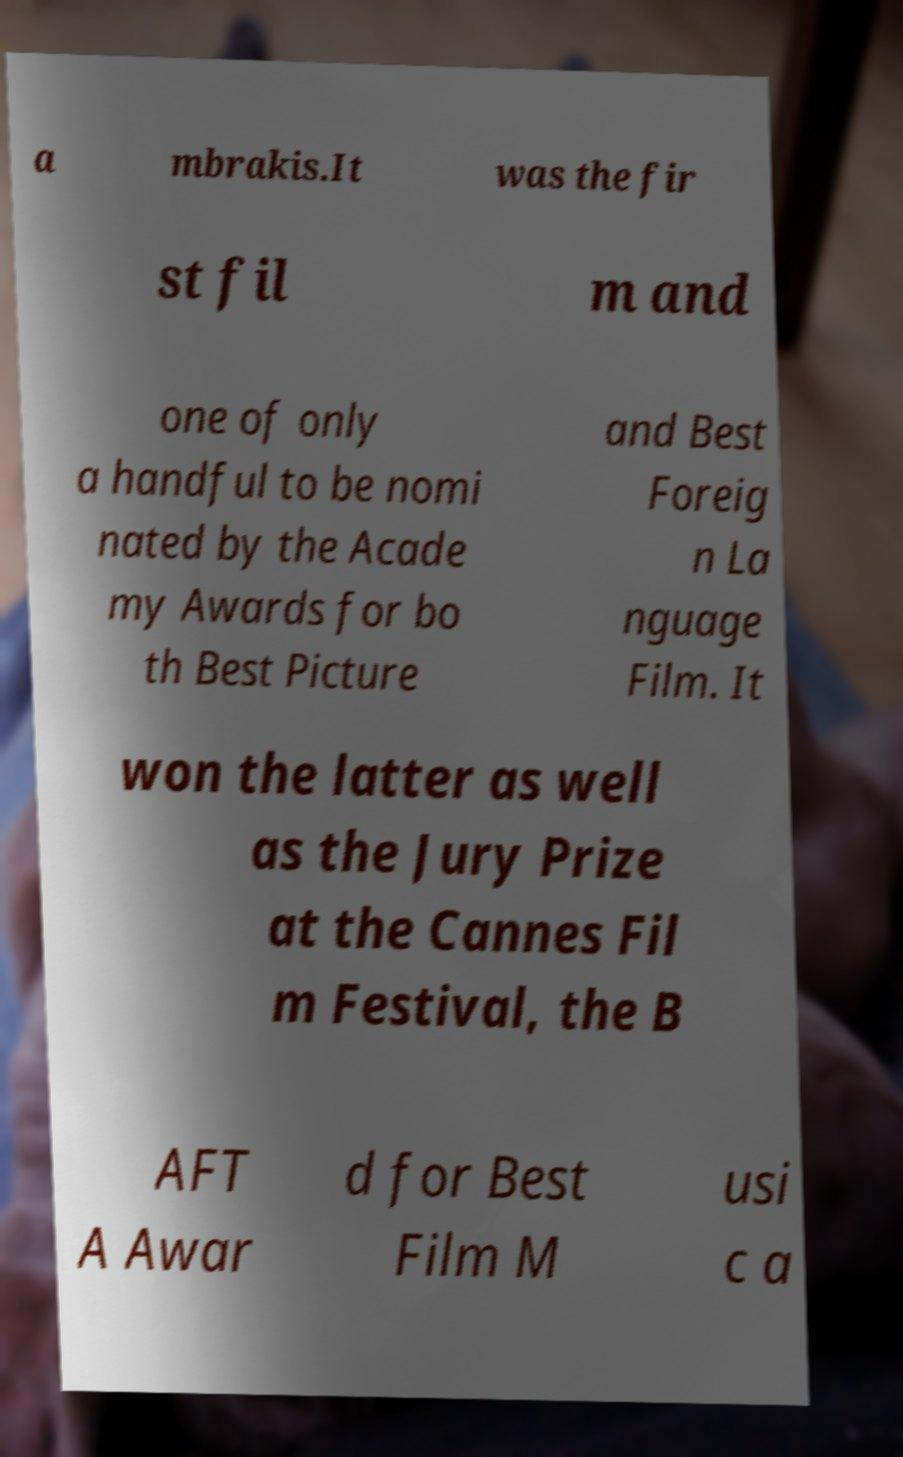Please identify and transcribe the text found in this image. a mbrakis.It was the fir st fil m and one of only a handful to be nomi nated by the Acade my Awards for bo th Best Picture and Best Foreig n La nguage Film. It won the latter as well as the Jury Prize at the Cannes Fil m Festival, the B AFT A Awar d for Best Film M usi c a 